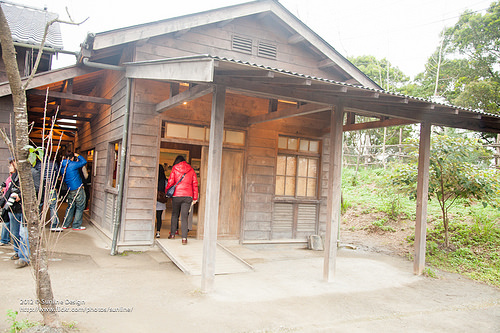<image>
Can you confirm if the window is to the right of the person? Yes. From this viewpoint, the window is positioned to the right side relative to the person. 